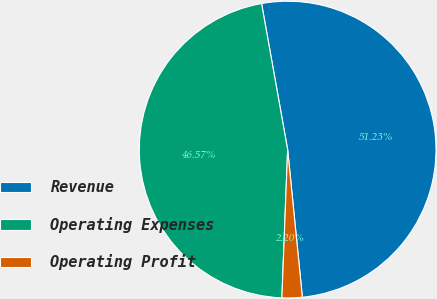Convert chart. <chart><loc_0><loc_0><loc_500><loc_500><pie_chart><fcel>Revenue<fcel>Operating Expenses<fcel>Operating Profit<nl><fcel>51.23%<fcel>46.57%<fcel>2.2%<nl></chart> 